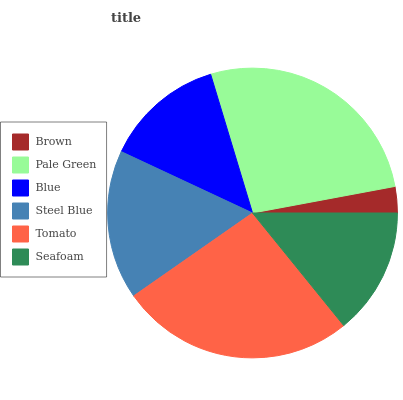Is Brown the minimum?
Answer yes or no. Yes. Is Pale Green the maximum?
Answer yes or no. Yes. Is Blue the minimum?
Answer yes or no. No. Is Blue the maximum?
Answer yes or no. No. Is Pale Green greater than Blue?
Answer yes or no. Yes. Is Blue less than Pale Green?
Answer yes or no. Yes. Is Blue greater than Pale Green?
Answer yes or no. No. Is Pale Green less than Blue?
Answer yes or no. No. Is Steel Blue the high median?
Answer yes or no. Yes. Is Seafoam the low median?
Answer yes or no. Yes. Is Seafoam the high median?
Answer yes or no. No. Is Brown the low median?
Answer yes or no. No. 